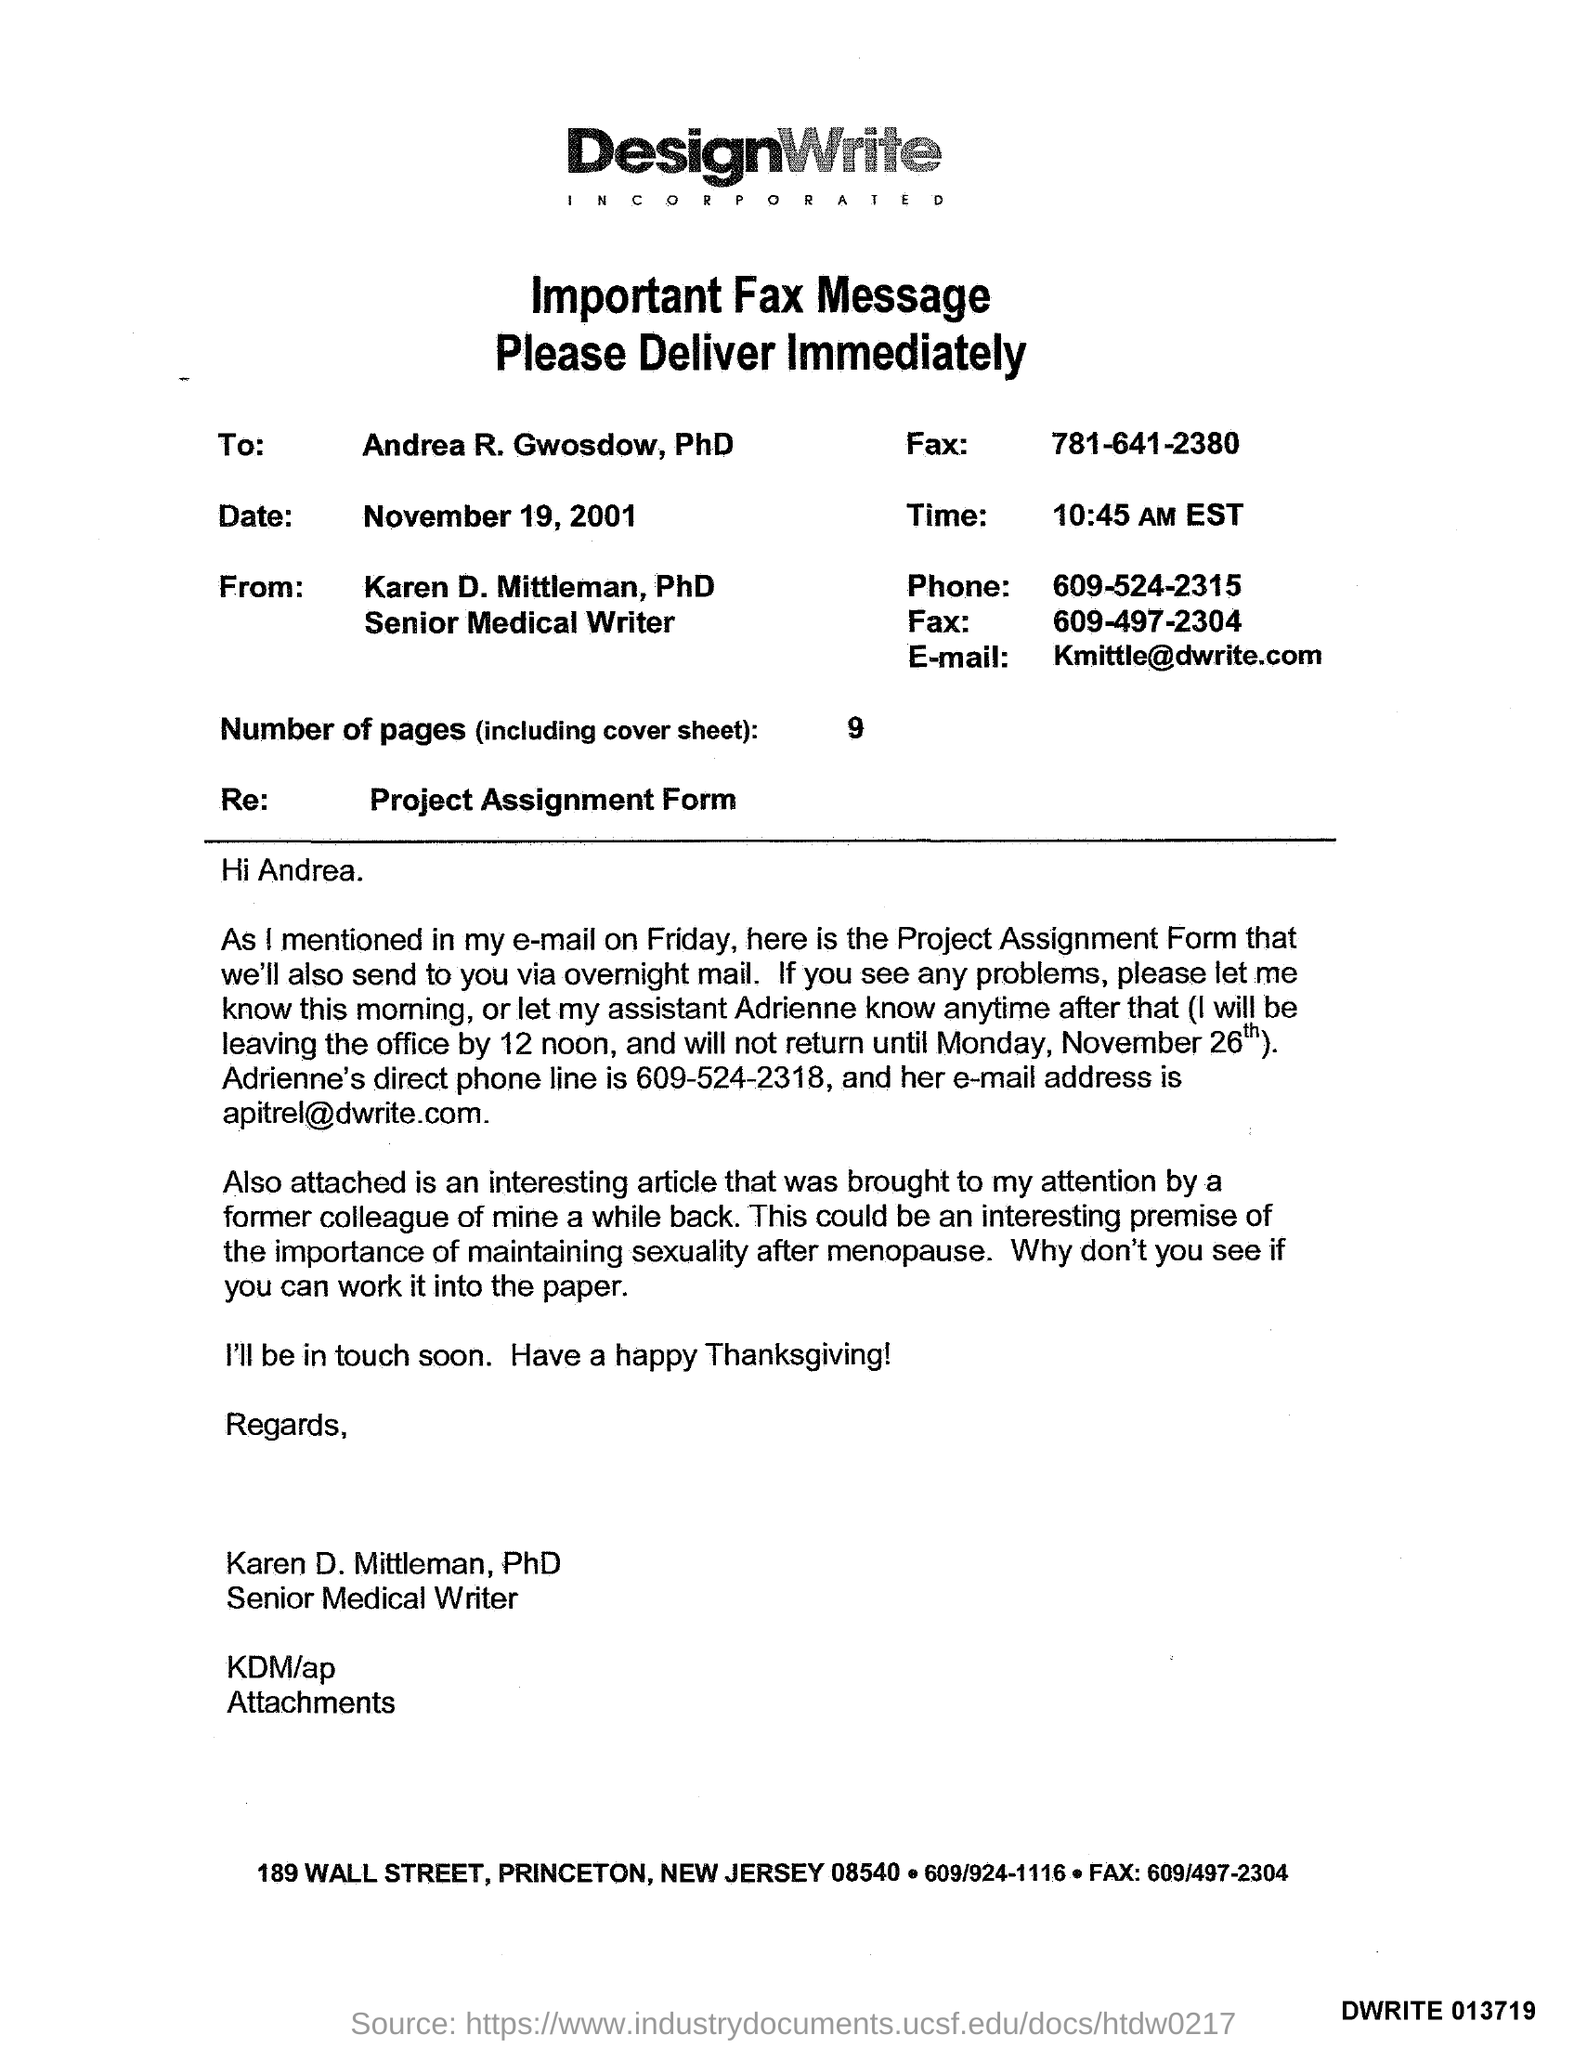Outline some significant characteristics in this image. I know the phone number to be 609-524-2315. The number of pages is 9. It is currently 10:45 AM EST. The email address is [kmittle@dwrite.com](mailto:kmittle@dwrite.com). 